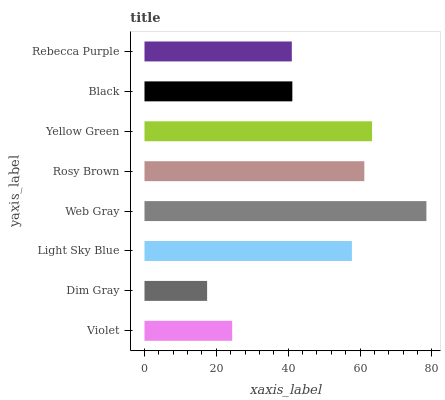Is Dim Gray the minimum?
Answer yes or no. Yes. Is Web Gray the maximum?
Answer yes or no. Yes. Is Light Sky Blue the minimum?
Answer yes or no. No. Is Light Sky Blue the maximum?
Answer yes or no. No. Is Light Sky Blue greater than Dim Gray?
Answer yes or no. Yes. Is Dim Gray less than Light Sky Blue?
Answer yes or no. Yes. Is Dim Gray greater than Light Sky Blue?
Answer yes or no. No. Is Light Sky Blue less than Dim Gray?
Answer yes or no. No. Is Light Sky Blue the high median?
Answer yes or no. Yes. Is Black the low median?
Answer yes or no. Yes. Is Rosy Brown the high median?
Answer yes or no. No. Is Light Sky Blue the low median?
Answer yes or no. No. 